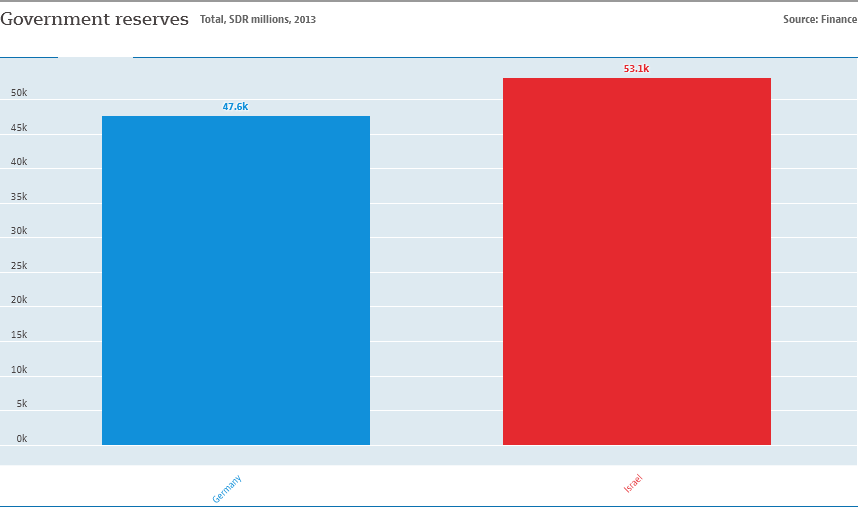Point out several critical features in this image. The sum value of the two bars is not lower than 100. The country with a government reserve value of 53,100 is Israel. 